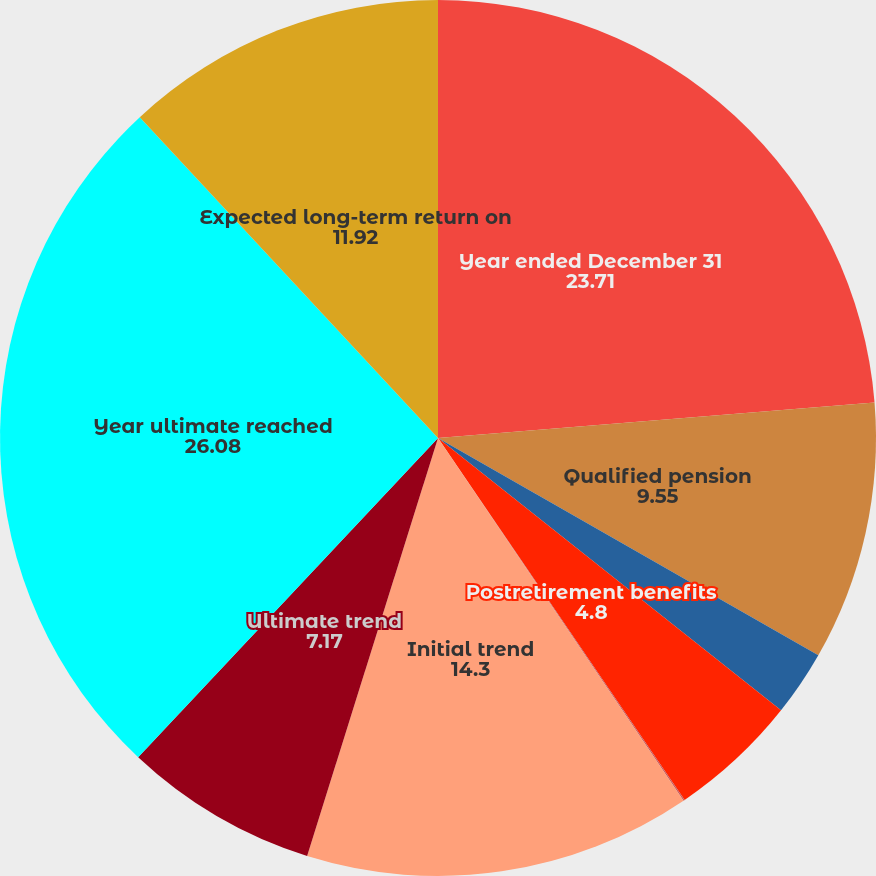Convert chart. <chart><loc_0><loc_0><loc_500><loc_500><pie_chart><fcel>Year ended December 31<fcel>Qualified pension<fcel>Nonqualified pension<fcel>Postretirement benefits<fcel>Rate of compensation increase<fcel>Initial trend<fcel>Ultimate trend<fcel>Year ultimate reached<fcel>Expected long-term return on<nl><fcel>23.71%<fcel>9.55%<fcel>2.42%<fcel>4.8%<fcel>0.05%<fcel>14.3%<fcel>7.17%<fcel>26.08%<fcel>11.92%<nl></chart> 